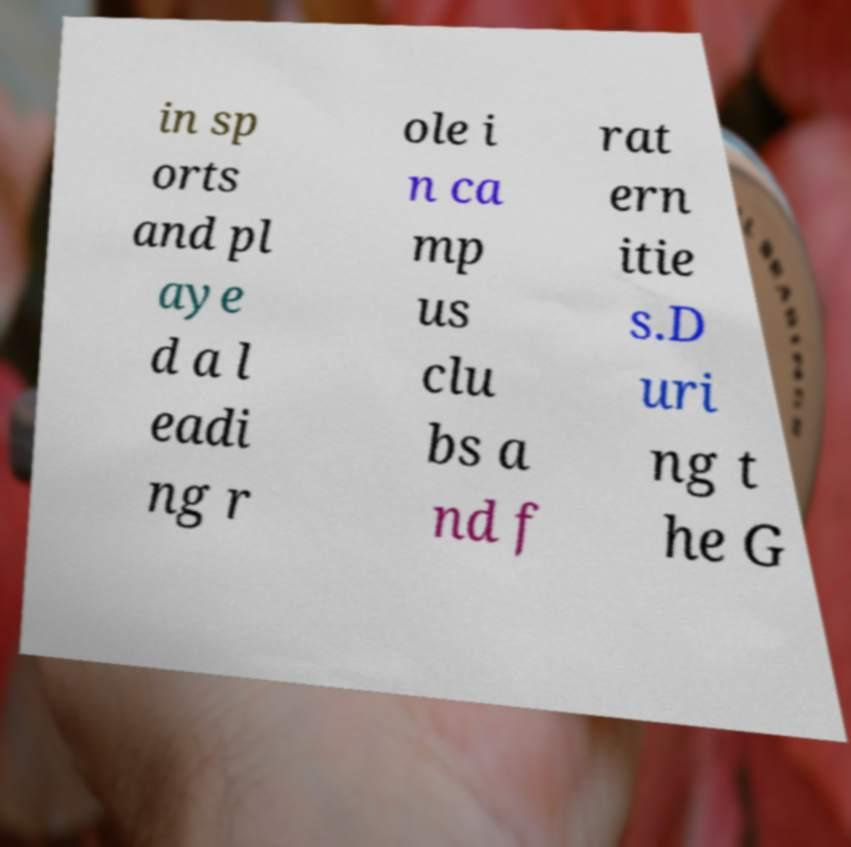Please identify and transcribe the text found in this image. in sp orts and pl aye d a l eadi ng r ole i n ca mp us clu bs a nd f rat ern itie s.D uri ng t he G 